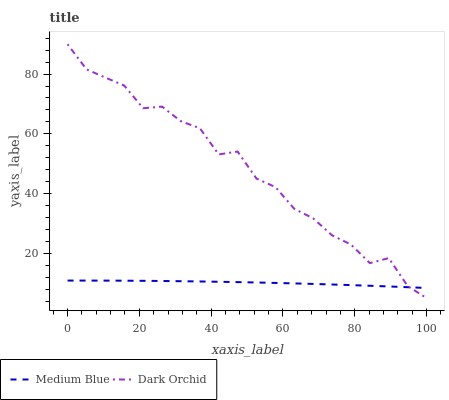Does Medium Blue have the minimum area under the curve?
Answer yes or no. Yes. Does Dark Orchid have the maximum area under the curve?
Answer yes or no. Yes. Does Dark Orchid have the minimum area under the curve?
Answer yes or no. No. Is Medium Blue the smoothest?
Answer yes or no. Yes. Is Dark Orchid the roughest?
Answer yes or no. Yes. Is Dark Orchid the smoothest?
Answer yes or no. No. Does Dark Orchid have the lowest value?
Answer yes or no. Yes. Does Dark Orchid have the highest value?
Answer yes or no. Yes. Does Dark Orchid intersect Medium Blue?
Answer yes or no. Yes. Is Dark Orchid less than Medium Blue?
Answer yes or no. No. Is Dark Orchid greater than Medium Blue?
Answer yes or no. No. 